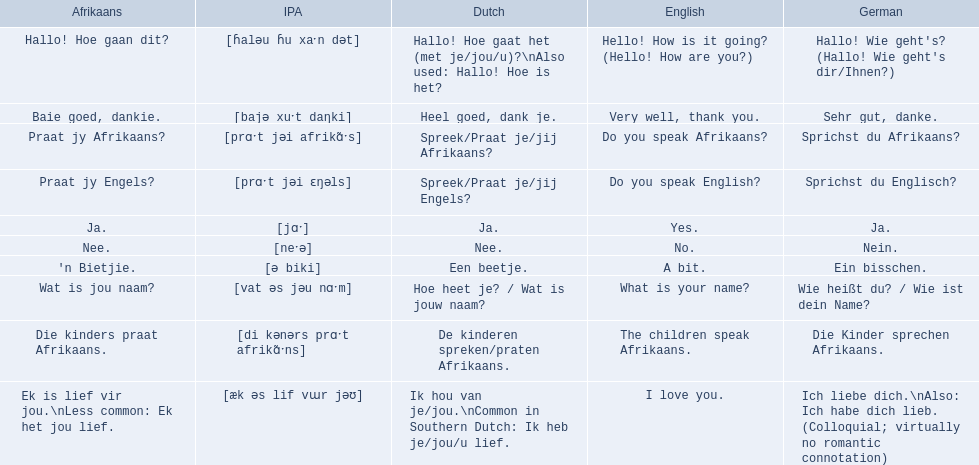How would you say the phrase the children speak afrikaans in afrikaans? Die kinders praat Afrikaans. How would you say the previous phrase in german? Die Kinder sprechen Afrikaans. Would you mind parsing the complete table? {'header': ['Afrikaans', 'IPA', 'Dutch', 'English', 'German'], 'rows': [['Hallo! Hoe gaan dit?', '[ɦaləu ɦu xaˑn dət]', 'Hallo! Hoe gaat het (met je/jou/u)?\\nAlso used: Hallo! Hoe is het?', 'Hello! How is it going? (Hello! How are you?)', "Hallo! Wie geht's? (Hallo! Wie geht's dir/Ihnen?)"], ['Baie goed, dankie.', '[bajə xuˑt daŋki]', 'Heel goed, dank je.', 'Very well, thank you.', 'Sehr gut, danke.'], ['Praat jy Afrikaans?', '[prɑˑt jəi afrikɑ̃ˑs]', 'Spreek/Praat je/jij Afrikaans?', 'Do you speak Afrikaans?', 'Sprichst du Afrikaans?'], ['Praat jy Engels?', '[prɑˑt jəi ɛŋəls]', 'Spreek/Praat je/jij Engels?', 'Do you speak English?', 'Sprichst du Englisch?'], ['Ja.', '[jɑˑ]', 'Ja.', 'Yes.', 'Ja.'], ['Nee.', '[neˑə]', 'Nee.', 'No.', 'Nein.'], ["'n Bietjie.", '[ə biki]', 'Een beetje.', 'A bit.', 'Ein bisschen.'], ['Wat is jou naam?', '[vat əs jəu nɑˑm]', 'Hoe heet je? / Wat is jouw naam?', 'What is your name?', 'Wie heißt du? / Wie ist dein Name?'], ['Die kinders praat Afrikaans.', '[di kənərs prɑˑt afrikɑ̃ˑns]', 'De kinderen spreken/praten Afrikaans.', 'The children speak Afrikaans.', 'Die Kinder sprechen Afrikaans.'], ['Ek is lief vir jou.\\nLess common: Ek het jou lief.', '[æk əs lif vɯr jəʊ]', 'Ik hou van je/jou.\\nCommon in Southern Dutch: Ik heb je/jou/u lief.', 'I love you.', 'Ich liebe dich.\\nAlso: Ich habe dich lieb. (Colloquial; virtually no romantic connotation)']]} 